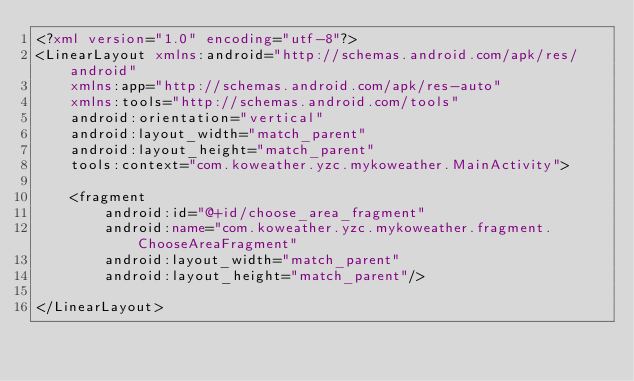<code> <loc_0><loc_0><loc_500><loc_500><_XML_><?xml version="1.0" encoding="utf-8"?>
<LinearLayout xmlns:android="http://schemas.android.com/apk/res/android"
    xmlns:app="http://schemas.android.com/apk/res-auto"
    xmlns:tools="http://schemas.android.com/tools"
    android:orientation="vertical"
    android:layout_width="match_parent"
    android:layout_height="match_parent"
    tools:context="com.koweather.yzc.mykoweather.MainActivity">

    <fragment
        android:id="@+id/choose_area_fragment"
        android:name="com.koweather.yzc.mykoweather.fragment.ChooseAreaFragment"
        android:layout_width="match_parent"
        android:layout_height="match_parent"/>

</LinearLayout>
</code> 